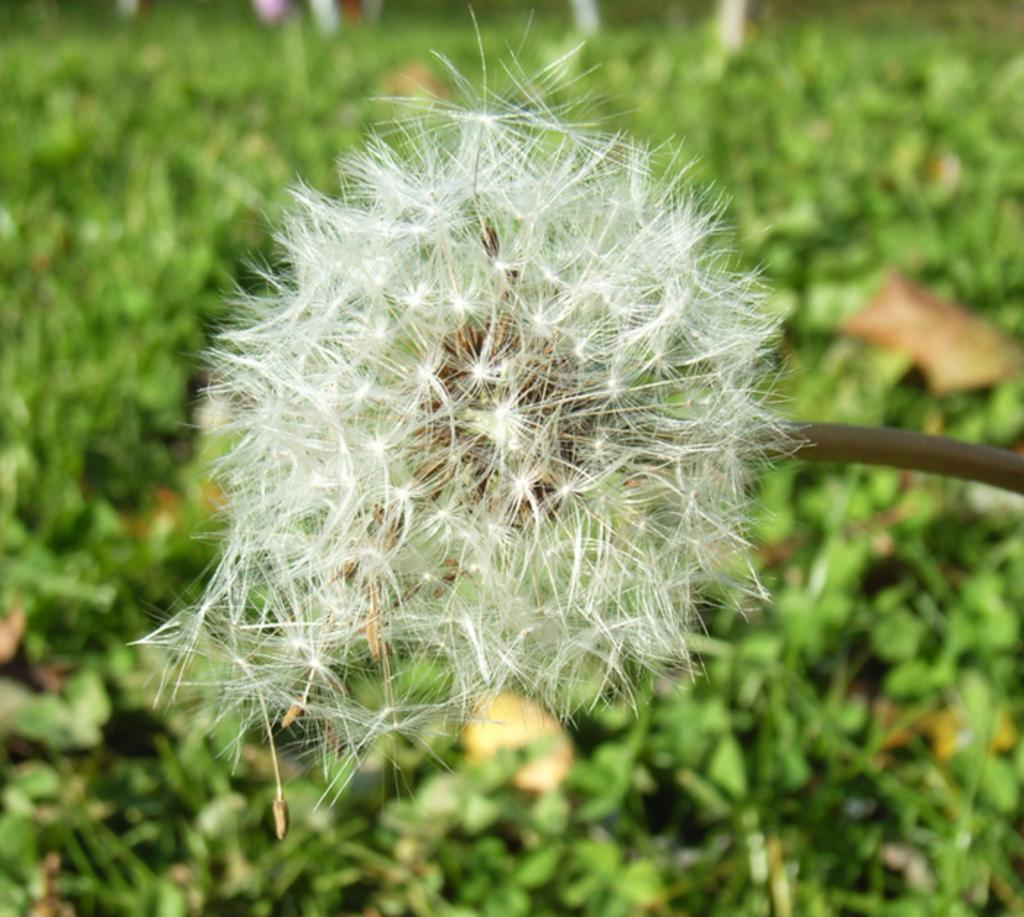What type of plant is the main subject of the image? There is a dandelion plant in the image. Are there any other plants visible in the image? Yes, there are other plants visible in the image. What type of jewel can be seen hanging from the dandelion plant in the image? There is no jewel present on the dandelion plant in the image. 